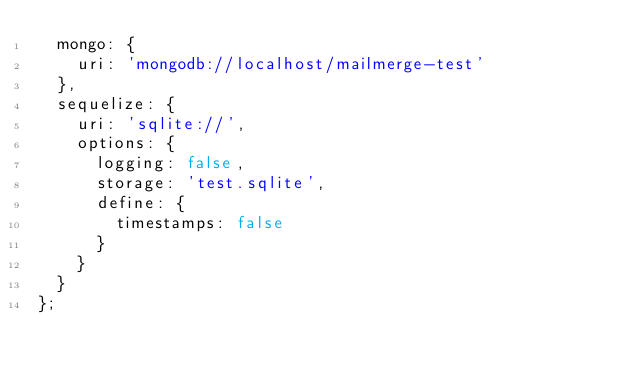Convert code to text. <code><loc_0><loc_0><loc_500><loc_500><_JavaScript_>  mongo: {
    uri: 'mongodb://localhost/mailmerge-test'
  },
  sequelize: {
    uri: 'sqlite://',
    options: {
      logging: false,
      storage: 'test.sqlite',
      define: {
        timestamps: false
      }
    }
  }
};
</code> 